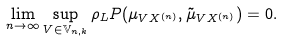Convert formula to latex. <formula><loc_0><loc_0><loc_500><loc_500>\lim _ { n \to \infty } \sup _ { V \in \mathbb { V } _ { n , k } } \rho _ { L } P ( \mu _ { V X ^ { ( n ) } } , \tilde { \mu } _ { V X ^ { ( n ) } } ) = 0 .</formula> 